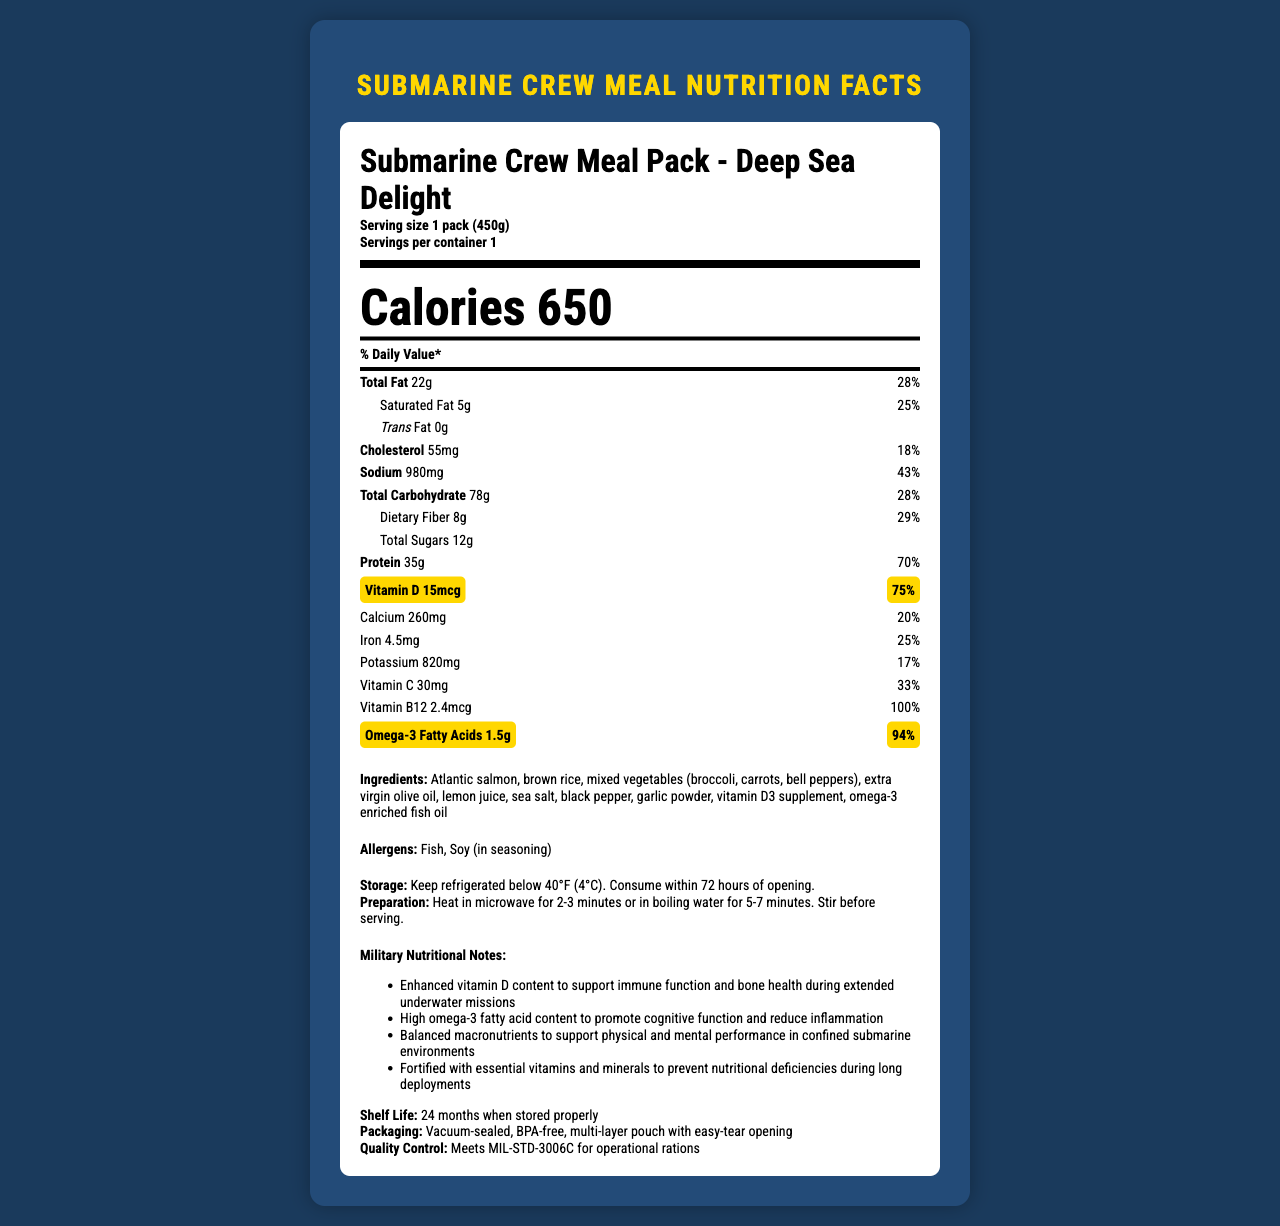what is the product name? The product name is displayed prominently at the top of the nutrition facts box.
Answer: Submarine Crew Meal Pack - Deep Sea Delight how much vitamin D does one pack contain? The amount of vitamin D per serving is listed in the nutrition facts box under the nutrients section.
Answer: 15mcg what percentage of the daily value of omega-3 fatty acids is in each serving? This information is provided next to the amount of omega-3 fatty acids listed in the nutrition facts box.
Answer: 94% list two ingredients in the Submarine Crew Meal Pack The ingredients list includes Atlantic salmon and brown rice, among others.
Answer: Atlantic salmon, brown rice how many calories are in one pack of the meal? The calorie count is displayed in large font in the nutrition facts box.
Answer: 650 what is the total fat content per serving? A. 10g B. 15g C. 22g D. 25g The total fat content is listed in the nutrition facts box as 22g.
Answer: C. 22g which nutrient has the highest daily value percentage? A. Protein B. Vitamin D C. Omega-3 Fatty Acids D. Sodium Protein has a daily value percentage of 70%, higher than vitamin D, omega-3 fatty acids, or sodium.
Answer: A. Protein does the meal pack contain any trans fat? The nutrition facts box lists trans fat as 0g.
Answer: No describe the main focus of the document The document offers comprehensive data on the nutrient composition, ingredients, and benefits of the meal pack, which is fortified with vitamins and minerals for submarine crews.
Answer: The document provides detailed nutritional information about the "Submarine Crew Meal Pack - Deep Sea Delight," focusing on its vitamin D and omega-3 fatty acid content, along with other essential nutrients, ingredients, storage, preparation instructions, and military nutritional benefits. what allergens are present in the meal pack? The allergens section lists fish and soy as the allergens present in the meal pack.
Answer: Fish, Soy (in seasoning) how long can the meal pack be stored if kept properly? The shelf life is given as 24 months when stored properly.
Answer: 24 months why is vitamin D emphasized in the nutritional notes? The military nutritional notes highlight the enhanced vitamin D content to help maintain crew health in submarine environments.
Answer: Vitamin D supports immune function and bone health during extended underwater missions. how many grams of dietary fiber does the meal contain? The dietary fiber content is listed at 8g in the nutrition facts box.
Answer: 8g is this meal pack suitable for someone with a fish allergy? One of the allergens listed is fish, making it unsuitable for someone with a fish allergy.
Answer: No what is the main benefit of the high omega-3 fatty acids content mentioned? The military nutritional notes mention that high omega-3 fatty acid content helps in promoting cognitive function and reducing inflammation.
Answer: To promote cognitive function and reduce inflammation what is the exact proportion of mixed vegetables in the ingredients? The document lists mixed vegetables as an ingredient but does not specify their proportion in the meal pack.
Answer: Not enough information 